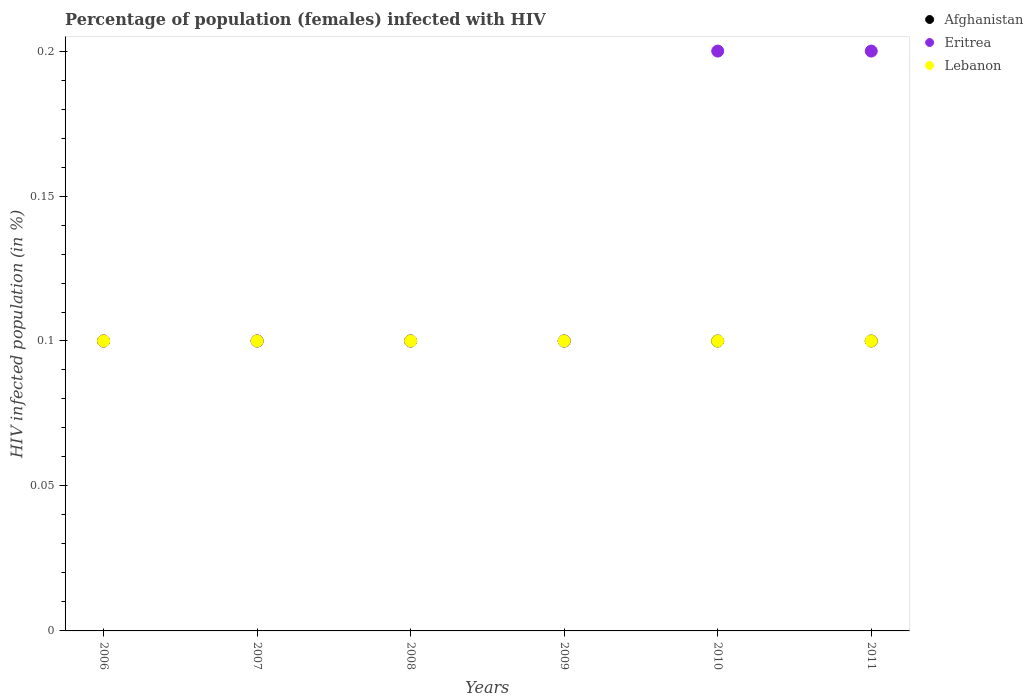How many different coloured dotlines are there?
Give a very brief answer. 3. Is the number of dotlines equal to the number of legend labels?
Offer a terse response. Yes. Across all years, what is the maximum percentage of HIV infected female population in Afghanistan?
Make the answer very short. 0.1. Across all years, what is the minimum percentage of HIV infected female population in Lebanon?
Your answer should be compact. 0.1. In which year was the percentage of HIV infected female population in Afghanistan minimum?
Offer a very short reply. 2006. What is the difference between the percentage of HIV infected female population in Eritrea in 2008 and that in 2010?
Your answer should be compact. -0.1. What is the average percentage of HIV infected female population in Afghanistan per year?
Your answer should be very brief. 0.1. Is the difference between the percentage of HIV infected female population in Lebanon in 2009 and 2010 greater than the difference between the percentage of HIV infected female population in Afghanistan in 2009 and 2010?
Make the answer very short. No. What is the difference between the highest and the lowest percentage of HIV infected female population in Eritrea?
Provide a short and direct response. 0.1. Is the sum of the percentage of HIV infected female population in Afghanistan in 2008 and 2011 greater than the maximum percentage of HIV infected female population in Lebanon across all years?
Give a very brief answer. Yes. Is it the case that in every year, the sum of the percentage of HIV infected female population in Afghanistan and percentage of HIV infected female population in Lebanon  is greater than the percentage of HIV infected female population in Eritrea?
Your answer should be compact. No. Does the percentage of HIV infected female population in Afghanistan monotonically increase over the years?
Provide a short and direct response. No. How many dotlines are there?
Offer a terse response. 3. Are the values on the major ticks of Y-axis written in scientific E-notation?
Your answer should be very brief. No. Does the graph contain any zero values?
Provide a short and direct response. No. What is the title of the graph?
Give a very brief answer. Percentage of population (females) infected with HIV. Does "Chad" appear as one of the legend labels in the graph?
Keep it short and to the point. No. What is the label or title of the X-axis?
Offer a terse response. Years. What is the label or title of the Y-axis?
Provide a succinct answer. HIV infected population (in %). What is the HIV infected population (in %) in Afghanistan in 2006?
Your answer should be compact. 0.1. What is the HIV infected population (in %) of Eritrea in 2006?
Offer a very short reply. 0.1. What is the HIV infected population (in %) in Lebanon in 2006?
Offer a very short reply. 0.1. What is the HIV infected population (in %) of Eritrea in 2007?
Your answer should be very brief. 0.1. What is the HIV infected population (in %) in Lebanon in 2007?
Give a very brief answer. 0.1. What is the HIV infected population (in %) in Eritrea in 2008?
Ensure brevity in your answer.  0.1. What is the HIV infected population (in %) of Afghanistan in 2009?
Provide a succinct answer. 0.1. What is the HIV infected population (in %) of Lebanon in 2009?
Ensure brevity in your answer.  0.1. What is the HIV infected population (in %) in Afghanistan in 2010?
Give a very brief answer. 0.1. What is the HIV infected population (in %) of Lebanon in 2010?
Your answer should be compact. 0.1. What is the HIV infected population (in %) of Afghanistan in 2011?
Give a very brief answer. 0.1. What is the HIV infected population (in %) of Eritrea in 2011?
Ensure brevity in your answer.  0.2. What is the HIV infected population (in %) in Lebanon in 2011?
Ensure brevity in your answer.  0.1. Across all years, what is the maximum HIV infected population (in %) of Afghanistan?
Keep it short and to the point. 0.1. Across all years, what is the maximum HIV infected population (in %) of Eritrea?
Your answer should be compact. 0.2. Across all years, what is the minimum HIV infected population (in %) of Eritrea?
Provide a succinct answer. 0.1. What is the total HIV infected population (in %) of Afghanistan in the graph?
Give a very brief answer. 0.6. What is the total HIV infected population (in %) of Eritrea in the graph?
Offer a very short reply. 0.8. What is the difference between the HIV infected population (in %) of Eritrea in 2006 and that in 2008?
Ensure brevity in your answer.  0. What is the difference between the HIV infected population (in %) in Lebanon in 2006 and that in 2008?
Your response must be concise. 0. What is the difference between the HIV infected population (in %) in Afghanistan in 2006 and that in 2009?
Offer a very short reply. 0. What is the difference between the HIV infected population (in %) of Lebanon in 2006 and that in 2009?
Ensure brevity in your answer.  0. What is the difference between the HIV infected population (in %) in Afghanistan in 2006 and that in 2010?
Your answer should be compact. 0. What is the difference between the HIV infected population (in %) in Afghanistan in 2006 and that in 2011?
Your answer should be very brief. 0. What is the difference between the HIV infected population (in %) in Lebanon in 2006 and that in 2011?
Your response must be concise. 0. What is the difference between the HIV infected population (in %) of Afghanistan in 2007 and that in 2008?
Your response must be concise. 0. What is the difference between the HIV infected population (in %) of Lebanon in 2007 and that in 2008?
Ensure brevity in your answer.  0. What is the difference between the HIV infected population (in %) in Afghanistan in 2007 and that in 2009?
Make the answer very short. 0. What is the difference between the HIV infected population (in %) in Afghanistan in 2008 and that in 2009?
Ensure brevity in your answer.  0. What is the difference between the HIV infected population (in %) in Eritrea in 2008 and that in 2009?
Your response must be concise. 0. What is the difference between the HIV infected population (in %) of Afghanistan in 2008 and that in 2010?
Offer a terse response. 0. What is the difference between the HIV infected population (in %) in Eritrea in 2008 and that in 2010?
Your response must be concise. -0.1. What is the difference between the HIV infected population (in %) of Eritrea in 2008 and that in 2011?
Your response must be concise. -0.1. What is the difference between the HIV infected population (in %) in Eritrea in 2009 and that in 2010?
Provide a short and direct response. -0.1. What is the difference between the HIV infected population (in %) of Eritrea in 2009 and that in 2011?
Keep it short and to the point. -0.1. What is the difference between the HIV infected population (in %) of Afghanistan in 2010 and that in 2011?
Provide a succinct answer. 0. What is the difference between the HIV infected population (in %) in Afghanistan in 2006 and the HIV infected population (in %) in Lebanon in 2007?
Offer a terse response. 0. What is the difference between the HIV infected population (in %) of Afghanistan in 2006 and the HIV infected population (in %) of Eritrea in 2010?
Provide a succinct answer. -0.1. What is the difference between the HIV infected population (in %) in Eritrea in 2006 and the HIV infected population (in %) in Lebanon in 2010?
Provide a short and direct response. 0. What is the difference between the HIV infected population (in %) in Eritrea in 2006 and the HIV infected population (in %) in Lebanon in 2011?
Your answer should be compact. 0. What is the difference between the HIV infected population (in %) of Afghanistan in 2007 and the HIV infected population (in %) of Eritrea in 2008?
Offer a terse response. 0. What is the difference between the HIV infected population (in %) of Afghanistan in 2007 and the HIV infected population (in %) of Lebanon in 2008?
Keep it short and to the point. 0. What is the difference between the HIV infected population (in %) of Afghanistan in 2007 and the HIV infected population (in %) of Lebanon in 2009?
Keep it short and to the point. 0. What is the difference between the HIV infected population (in %) of Eritrea in 2007 and the HIV infected population (in %) of Lebanon in 2009?
Offer a very short reply. 0. What is the difference between the HIV infected population (in %) of Afghanistan in 2007 and the HIV infected population (in %) of Eritrea in 2010?
Keep it short and to the point. -0.1. What is the difference between the HIV infected population (in %) in Afghanistan in 2007 and the HIV infected population (in %) in Lebanon in 2010?
Offer a terse response. 0. What is the difference between the HIV infected population (in %) in Eritrea in 2007 and the HIV infected population (in %) in Lebanon in 2010?
Offer a terse response. 0. What is the difference between the HIV infected population (in %) in Eritrea in 2007 and the HIV infected population (in %) in Lebanon in 2011?
Your answer should be compact. 0. What is the difference between the HIV infected population (in %) of Afghanistan in 2008 and the HIV infected population (in %) of Lebanon in 2009?
Provide a succinct answer. 0. What is the difference between the HIV infected population (in %) of Eritrea in 2008 and the HIV infected population (in %) of Lebanon in 2009?
Your response must be concise. 0. What is the difference between the HIV infected population (in %) of Eritrea in 2008 and the HIV infected population (in %) of Lebanon in 2011?
Your response must be concise. 0. What is the difference between the HIV infected population (in %) in Afghanistan in 2009 and the HIV infected population (in %) in Eritrea in 2010?
Offer a terse response. -0.1. What is the difference between the HIV infected population (in %) of Afghanistan in 2009 and the HIV infected population (in %) of Lebanon in 2010?
Provide a succinct answer. 0. What is the difference between the HIV infected population (in %) in Eritrea in 2009 and the HIV infected population (in %) in Lebanon in 2010?
Offer a terse response. 0. What is the difference between the HIV infected population (in %) in Eritrea in 2009 and the HIV infected population (in %) in Lebanon in 2011?
Offer a terse response. 0. What is the difference between the HIV infected population (in %) of Afghanistan in 2010 and the HIV infected population (in %) of Eritrea in 2011?
Ensure brevity in your answer.  -0.1. What is the difference between the HIV infected population (in %) in Eritrea in 2010 and the HIV infected population (in %) in Lebanon in 2011?
Your answer should be compact. 0.1. What is the average HIV infected population (in %) of Afghanistan per year?
Ensure brevity in your answer.  0.1. What is the average HIV infected population (in %) in Eritrea per year?
Your answer should be compact. 0.13. In the year 2006, what is the difference between the HIV infected population (in %) in Afghanistan and HIV infected population (in %) in Lebanon?
Keep it short and to the point. 0. In the year 2006, what is the difference between the HIV infected population (in %) of Eritrea and HIV infected population (in %) of Lebanon?
Ensure brevity in your answer.  0. In the year 2007, what is the difference between the HIV infected population (in %) of Afghanistan and HIV infected population (in %) of Eritrea?
Ensure brevity in your answer.  0. In the year 2007, what is the difference between the HIV infected population (in %) of Afghanistan and HIV infected population (in %) of Lebanon?
Make the answer very short. 0. In the year 2007, what is the difference between the HIV infected population (in %) of Eritrea and HIV infected population (in %) of Lebanon?
Offer a very short reply. 0. In the year 2008, what is the difference between the HIV infected population (in %) in Afghanistan and HIV infected population (in %) in Eritrea?
Offer a very short reply. 0. In the year 2008, what is the difference between the HIV infected population (in %) in Afghanistan and HIV infected population (in %) in Lebanon?
Give a very brief answer. 0. In the year 2010, what is the difference between the HIV infected population (in %) of Afghanistan and HIV infected population (in %) of Lebanon?
Provide a succinct answer. 0. In the year 2011, what is the difference between the HIV infected population (in %) in Afghanistan and HIV infected population (in %) in Eritrea?
Your answer should be compact. -0.1. What is the ratio of the HIV infected population (in %) of Eritrea in 2006 to that in 2007?
Give a very brief answer. 1. What is the ratio of the HIV infected population (in %) of Afghanistan in 2006 to that in 2008?
Keep it short and to the point. 1. What is the ratio of the HIV infected population (in %) of Eritrea in 2006 to that in 2008?
Provide a succinct answer. 1. What is the ratio of the HIV infected population (in %) of Afghanistan in 2006 to that in 2009?
Offer a very short reply. 1. What is the ratio of the HIV infected population (in %) of Lebanon in 2006 to that in 2009?
Provide a succinct answer. 1. What is the ratio of the HIV infected population (in %) of Afghanistan in 2006 to that in 2010?
Keep it short and to the point. 1. What is the ratio of the HIV infected population (in %) of Eritrea in 2006 to that in 2010?
Your answer should be very brief. 0.5. What is the ratio of the HIV infected population (in %) of Lebanon in 2006 to that in 2010?
Give a very brief answer. 1. What is the ratio of the HIV infected population (in %) in Afghanistan in 2006 to that in 2011?
Keep it short and to the point. 1. What is the ratio of the HIV infected population (in %) in Eritrea in 2006 to that in 2011?
Keep it short and to the point. 0.5. What is the ratio of the HIV infected population (in %) of Afghanistan in 2007 to that in 2008?
Your answer should be very brief. 1. What is the ratio of the HIV infected population (in %) of Eritrea in 2007 to that in 2008?
Keep it short and to the point. 1. What is the ratio of the HIV infected population (in %) in Afghanistan in 2007 to that in 2009?
Your answer should be very brief. 1. What is the ratio of the HIV infected population (in %) of Lebanon in 2007 to that in 2009?
Your response must be concise. 1. What is the ratio of the HIV infected population (in %) of Eritrea in 2007 to that in 2010?
Give a very brief answer. 0.5. What is the ratio of the HIV infected population (in %) in Lebanon in 2007 to that in 2010?
Ensure brevity in your answer.  1. What is the ratio of the HIV infected population (in %) in Afghanistan in 2007 to that in 2011?
Make the answer very short. 1. What is the ratio of the HIV infected population (in %) in Eritrea in 2007 to that in 2011?
Keep it short and to the point. 0.5. What is the ratio of the HIV infected population (in %) in Lebanon in 2008 to that in 2009?
Offer a terse response. 1. What is the ratio of the HIV infected population (in %) of Afghanistan in 2008 to that in 2010?
Give a very brief answer. 1. What is the ratio of the HIV infected population (in %) in Eritrea in 2008 to that in 2010?
Keep it short and to the point. 0.5. What is the ratio of the HIV infected population (in %) in Afghanistan in 2008 to that in 2011?
Offer a very short reply. 1. What is the ratio of the HIV infected population (in %) in Eritrea in 2008 to that in 2011?
Ensure brevity in your answer.  0.5. What is the ratio of the HIV infected population (in %) of Lebanon in 2009 to that in 2010?
Make the answer very short. 1. What is the ratio of the HIV infected population (in %) of Afghanistan in 2009 to that in 2011?
Your response must be concise. 1. What is the ratio of the HIV infected population (in %) in Lebanon in 2009 to that in 2011?
Provide a succinct answer. 1. What is the ratio of the HIV infected population (in %) of Afghanistan in 2010 to that in 2011?
Offer a terse response. 1. What is the ratio of the HIV infected population (in %) of Eritrea in 2010 to that in 2011?
Make the answer very short. 1. What is the difference between the highest and the lowest HIV infected population (in %) in Eritrea?
Provide a short and direct response. 0.1. 